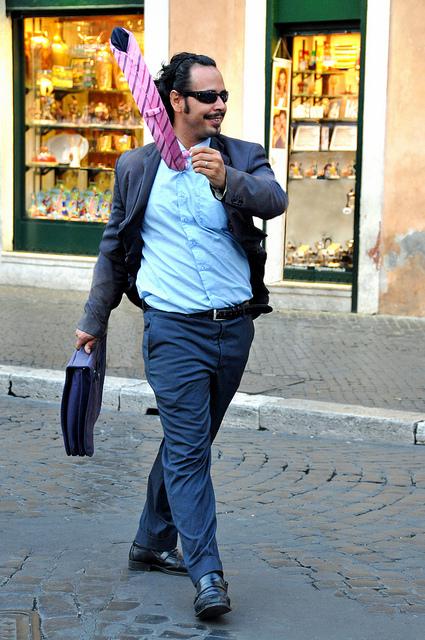Which direction is the wind blowing?
Short answer required. Left. What is the man holding?
Write a very short answer. Briefcase. Is he carrying a briefcase?
Short answer required. Yes. What color is the man's tie?
Give a very brief answer. Pink. Is the man happy?
Be succinct. Yes. 